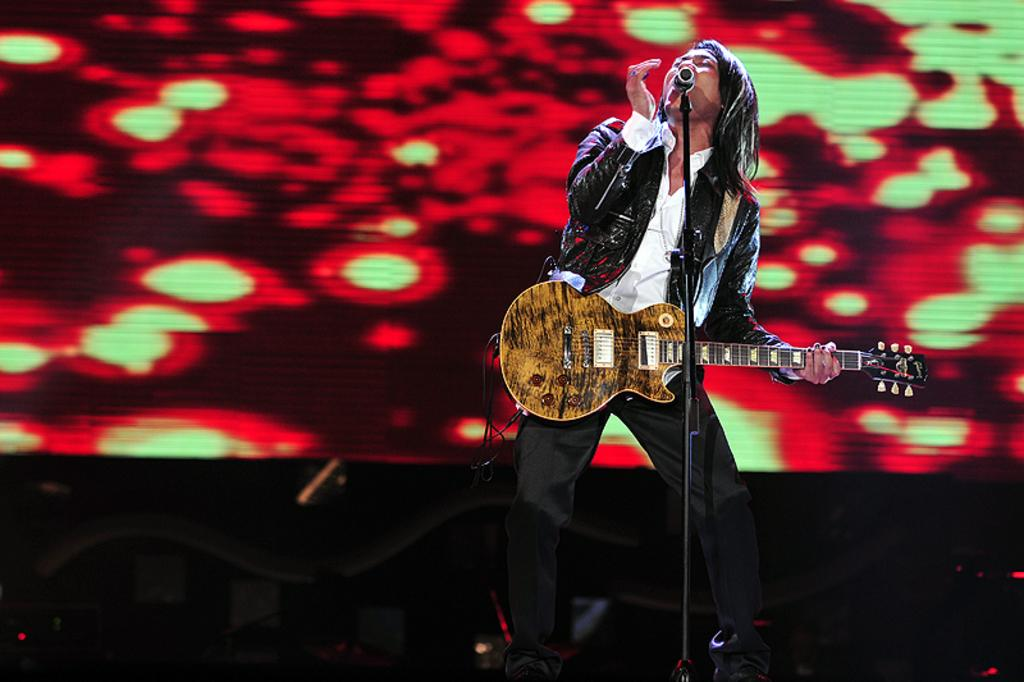What is the main subject of the image? There is a person in the image. What is the person doing in the image? The person is standing in the image. What object is the person holding in the image? The person is holding a guitar in his hand. What type of footwear is the person wearing in the image? The provided facts do not mention any footwear, so it cannot be determined from the image. 